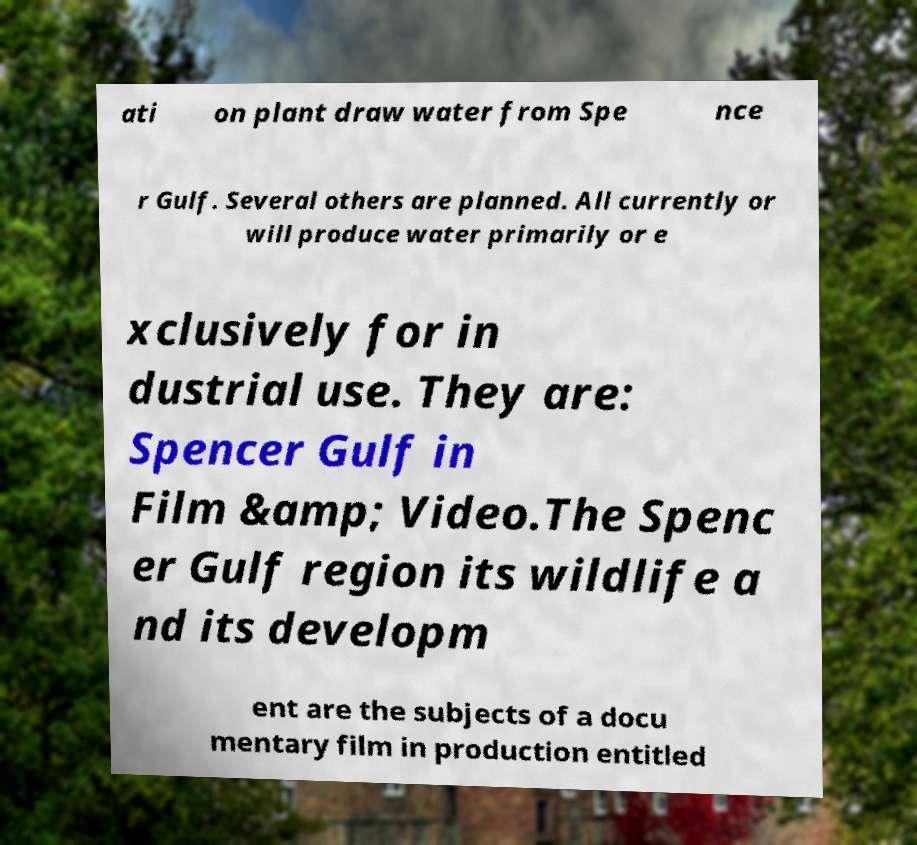Can you read and provide the text displayed in the image?This photo seems to have some interesting text. Can you extract and type it out for me? ati on plant draw water from Spe nce r Gulf. Several others are planned. All currently or will produce water primarily or e xclusively for in dustrial use. They are: Spencer Gulf in Film &amp; Video.The Spenc er Gulf region its wildlife a nd its developm ent are the subjects of a docu mentary film in production entitled 